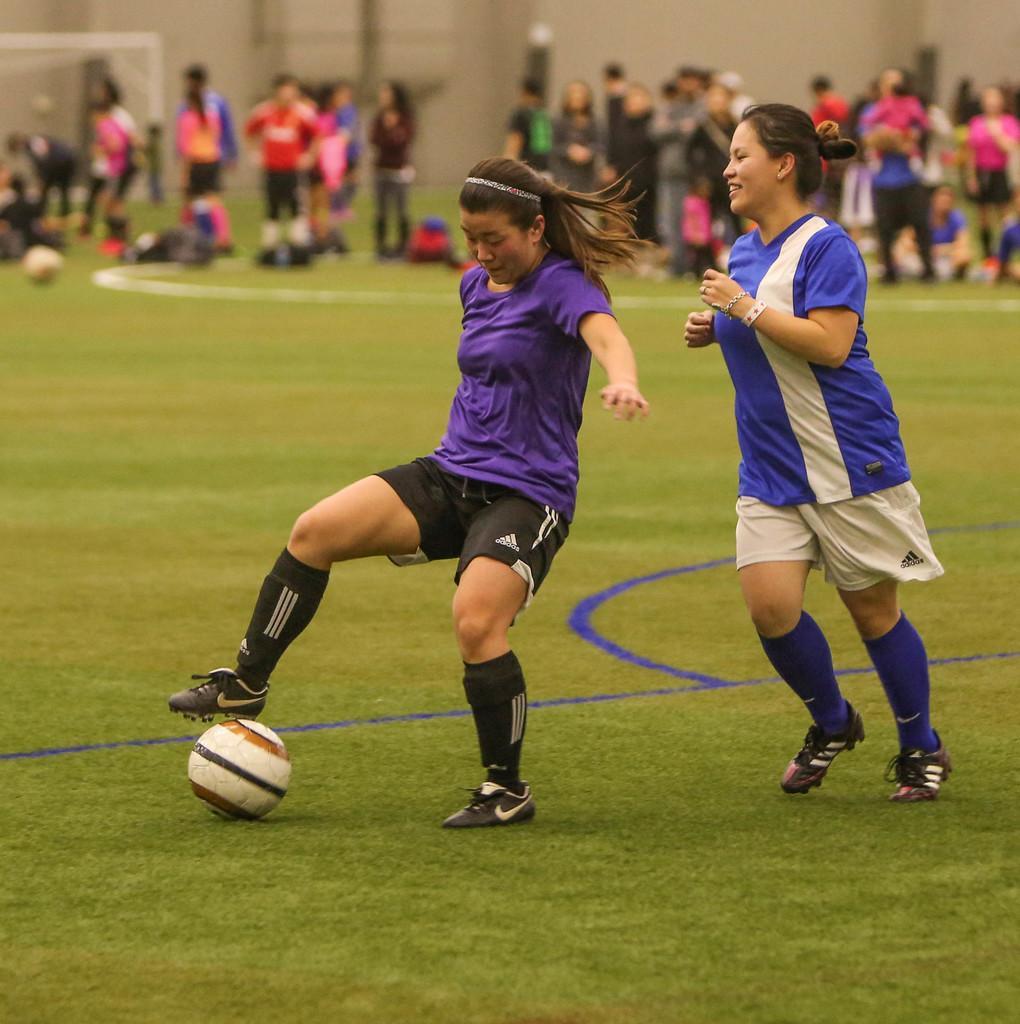How would you summarize this image in a sentence or two? There are two women playing with a ball in the ground. In the background there are some people standing and some of them was sitting. We can observe a wall here along with a goal post. 